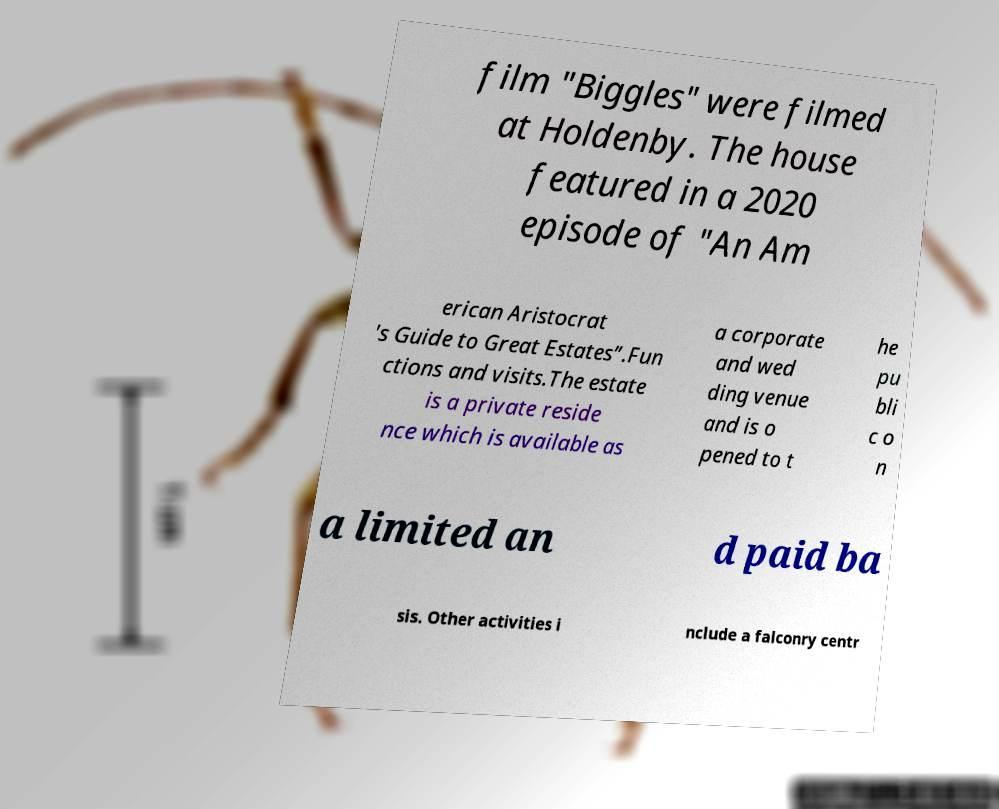Can you read and provide the text displayed in the image?This photo seems to have some interesting text. Can you extract and type it out for me? film "Biggles" were filmed at Holdenby. The house featured in a 2020 episode of "An Am erican Aristocrat 's Guide to Great Estates”.Fun ctions and visits.The estate is a private reside nce which is available as a corporate and wed ding venue and is o pened to t he pu bli c o n a limited an d paid ba sis. Other activities i nclude a falconry centr 